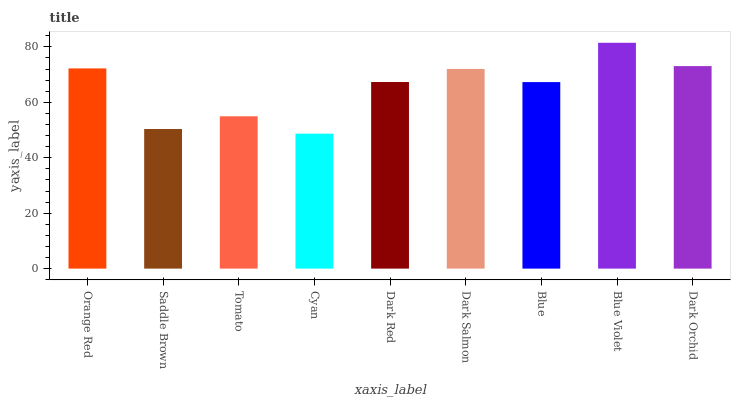Is Cyan the minimum?
Answer yes or no. Yes. Is Blue Violet the maximum?
Answer yes or no. Yes. Is Saddle Brown the minimum?
Answer yes or no. No. Is Saddle Brown the maximum?
Answer yes or no. No. Is Orange Red greater than Saddle Brown?
Answer yes or no. Yes. Is Saddle Brown less than Orange Red?
Answer yes or no. Yes. Is Saddle Brown greater than Orange Red?
Answer yes or no. No. Is Orange Red less than Saddle Brown?
Answer yes or no. No. Is Dark Red the high median?
Answer yes or no. Yes. Is Dark Red the low median?
Answer yes or no. Yes. Is Blue the high median?
Answer yes or no. No. Is Dark Orchid the low median?
Answer yes or no. No. 